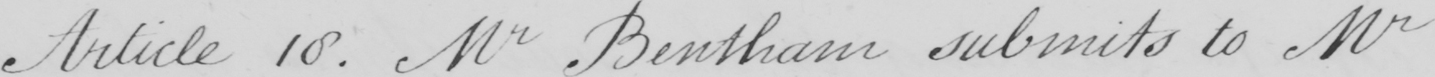Can you read and transcribe this handwriting? Article 18 . Mr Bentham submits to Mr 